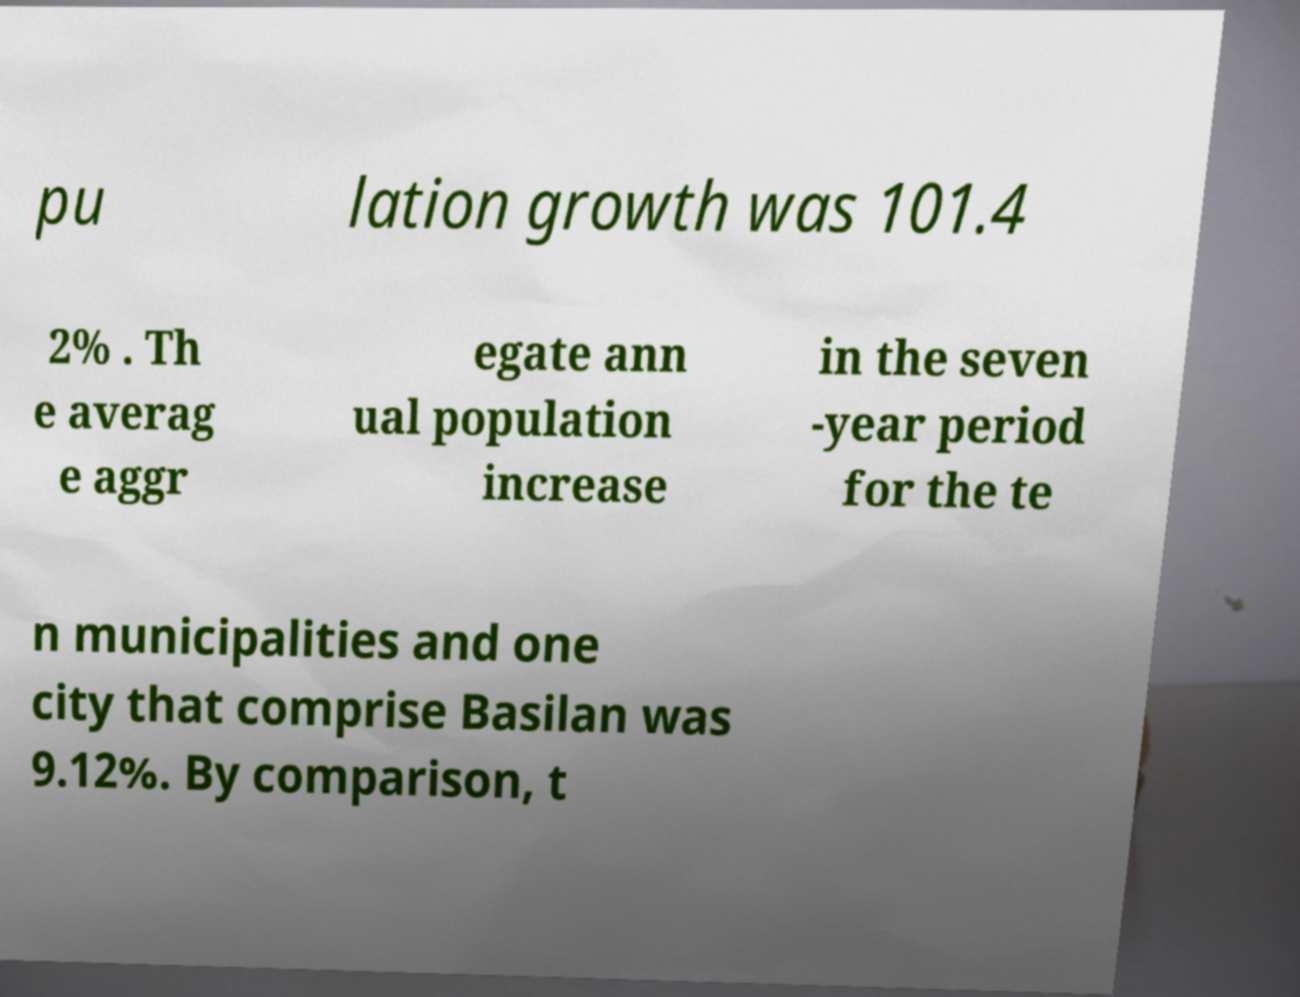Can you read and provide the text displayed in the image?This photo seems to have some interesting text. Can you extract and type it out for me? pu lation growth was 101.4 2% . Th e averag e aggr egate ann ual population increase in the seven -year period for the te n municipalities and one city that comprise Basilan was 9.12%. By comparison, t 